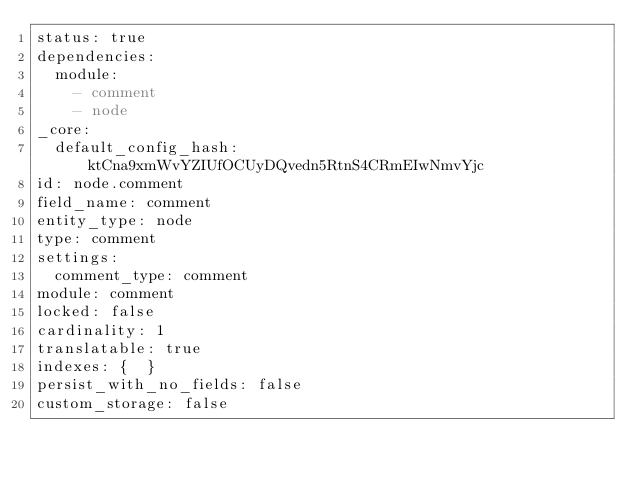Convert code to text. <code><loc_0><loc_0><loc_500><loc_500><_YAML_>status: true
dependencies:
  module:
    - comment
    - node
_core:
  default_config_hash: ktCna9xmWvYZIUfOCUyDQvedn5RtnS4CRmEIwNmvYjc
id: node.comment
field_name: comment
entity_type: node
type: comment
settings:
  comment_type: comment
module: comment
locked: false
cardinality: 1
translatable: true
indexes: {  }
persist_with_no_fields: false
custom_storage: false
</code> 